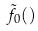Convert formula to latex. <formula><loc_0><loc_0><loc_500><loc_500>\tilde { f } _ { 0 } ( )</formula> 